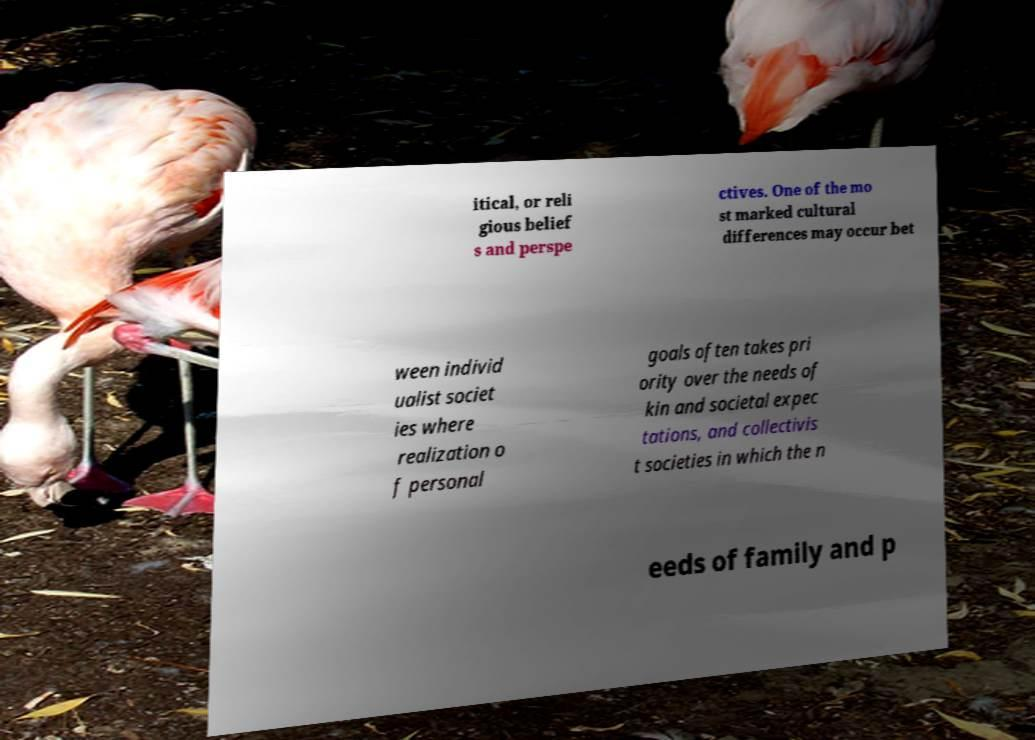Could you assist in decoding the text presented in this image and type it out clearly? itical, or reli gious belief s and perspe ctives. One of the mo st marked cultural differences may occur bet ween individ ualist societ ies where realization o f personal goals often takes pri ority over the needs of kin and societal expec tations, and collectivis t societies in which the n eeds of family and p 